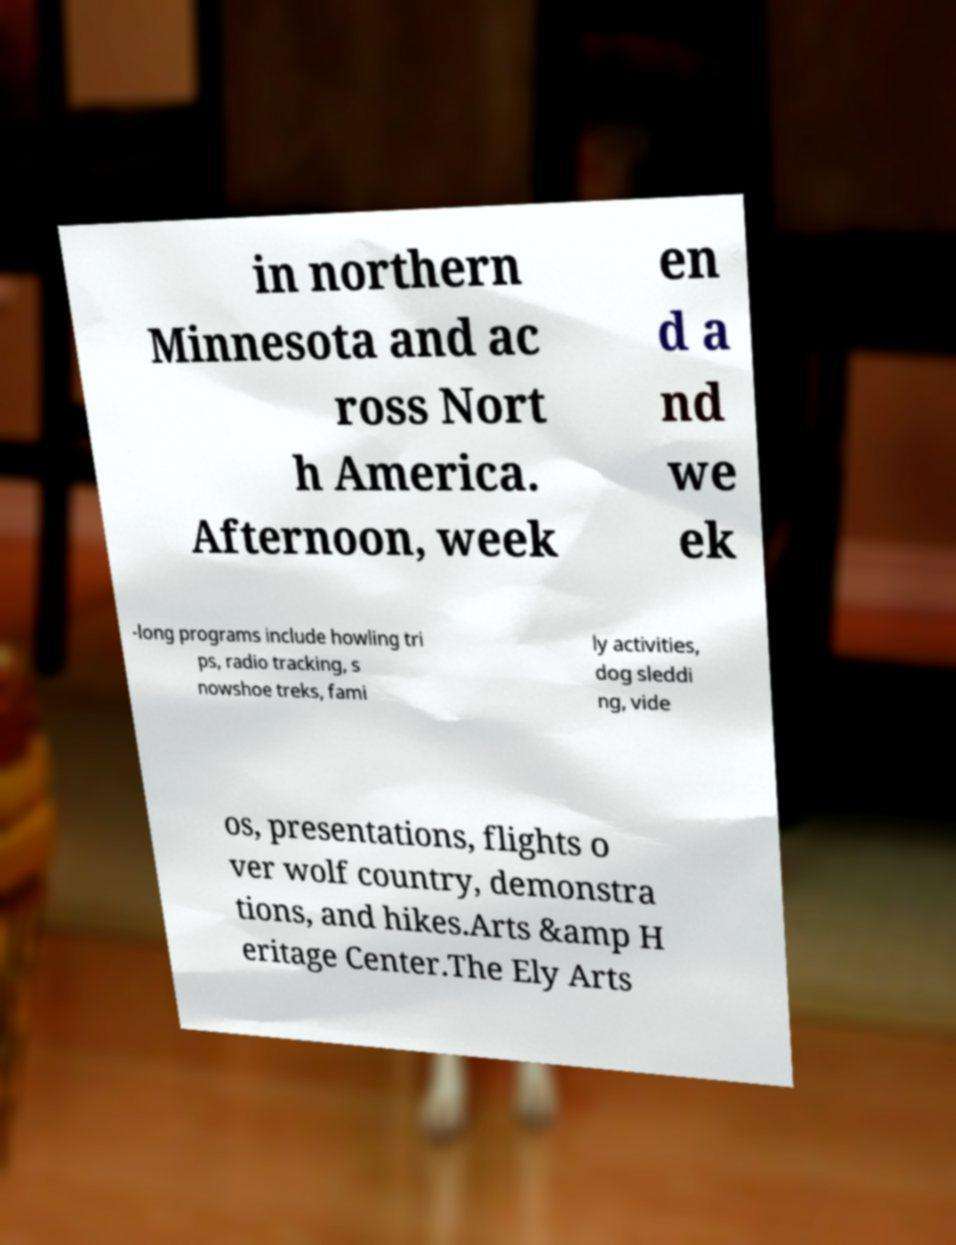Could you assist in decoding the text presented in this image and type it out clearly? in northern Minnesota and ac ross Nort h America. Afternoon, week en d a nd we ek -long programs include howling tri ps, radio tracking, s nowshoe treks, fami ly activities, dog sleddi ng, vide os, presentations, flights o ver wolf country, demonstra tions, and hikes.Arts &amp H eritage Center.The Ely Arts 